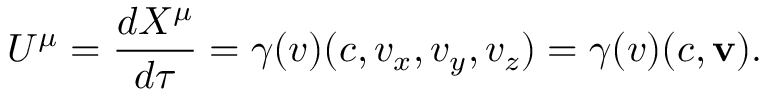Convert formula to latex. <formula><loc_0><loc_0><loc_500><loc_500>U ^ { \mu } = { \frac { d X ^ { \mu } } { d \tau } } = \gamma ( v ) ( c , v _ { x } , v _ { y } , v _ { z } ) = \gamma ( v ) ( c , v ) .</formula> 